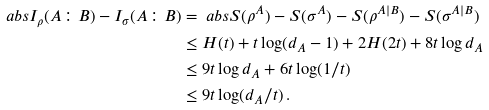<formula> <loc_0><loc_0><loc_500><loc_500>\ a b s { I _ { \rho } ( A \colon B ) - I _ { \sigma } ( A \colon B ) } & = \ a b s { S ( \rho ^ { A } ) - S ( \sigma ^ { A } ) - S ( \rho ^ { A | B } ) - S ( \sigma ^ { A | B } ) } \\ & \leq H ( t ) + t \log ( d _ { A } - 1 ) + 2 H ( 2 t ) + 8 t \log d _ { A } \\ & \leq 9 t \log d _ { A } + 6 t \log ( 1 / t ) \\ & \leq 9 t \log ( d _ { A } / t ) \, .</formula> 